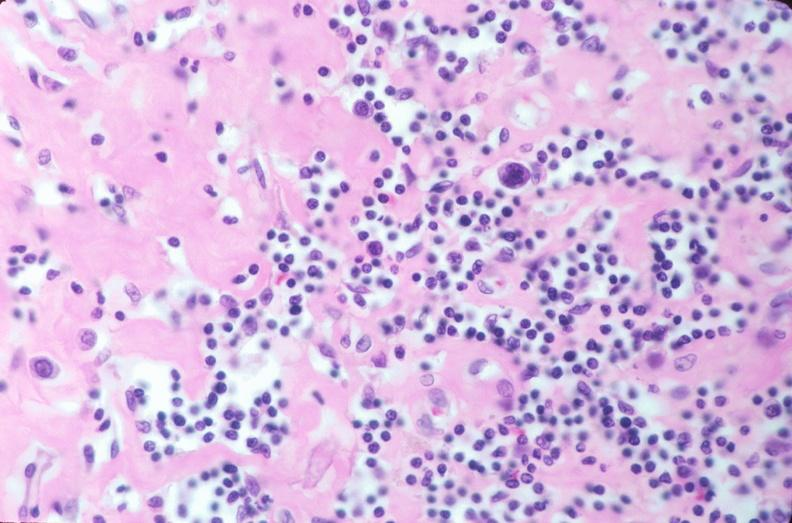what does this image show?
Answer the question using a single word or phrase. Lymph nodes 